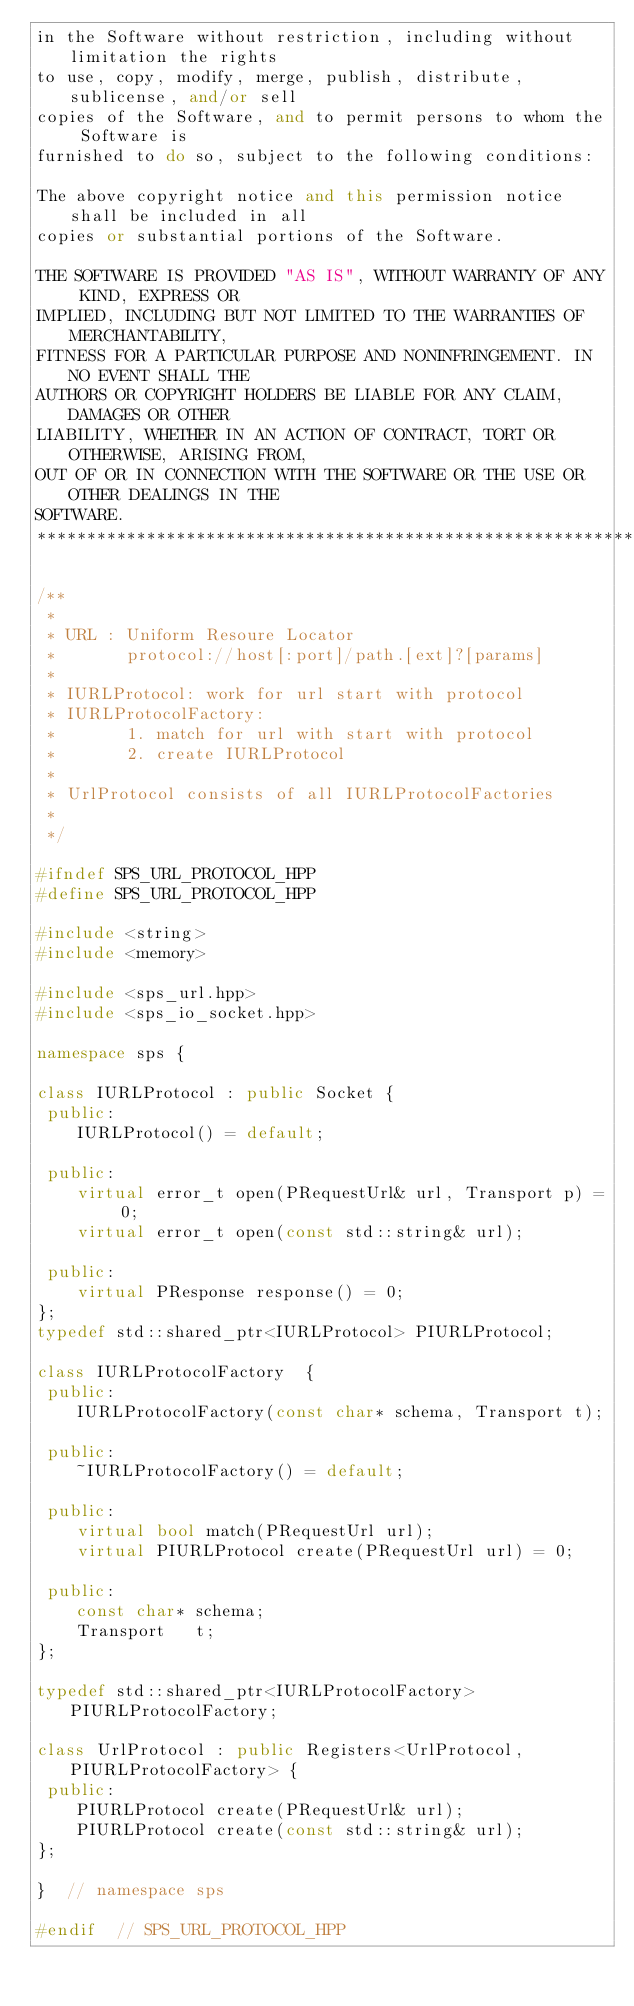Convert code to text. <code><loc_0><loc_0><loc_500><loc_500><_C++_>in the Software without restriction, including without limitation the rights
to use, copy, modify, merge, publish, distribute, sublicense, and/or sell
copies of the Software, and to permit persons to whom the Software is
furnished to do so, subject to the following conditions:

The above copyright notice and this permission notice shall be included in all
copies or substantial portions of the Software.

THE SOFTWARE IS PROVIDED "AS IS", WITHOUT WARRANTY OF ANY KIND, EXPRESS OR
IMPLIED, INCLUDING BUT NOT LIMITED TO THE WARRANTIES OF MERCHANTABILITY,
FITNESS FOR A PARTICULAR PURPOSE AND NONINFRINGEMENT. IN NO EVENT SHALL THE
AUTHORS OR COPYRIGHT HOLDERS BE LIABLE FOR ANY CLAIM, DAMAGES OR OTHER
LIABILITY, WHETHER IN AN ACTION OF CONTRACT, TORT OR OTHERWISE, ARISING FROM,
OUT OF OR IN CONNECTION WITH THE SOFTWARE OR THE USE OR OTHER DEALINGS IN THE
SOFTWARE.
*****************************************************************************/

/**
 *
 * URL : Uniform Resoure Locator
 *       protocol://host[:port]/path.[ext]?[params]
 *
 * IURLProtocol: work for url start with protocol
 * IURLProtocolFactory:
 *       1. match for url with start with protocol
 *       2. create IURLProtocol
 *
 * UrlProtocol consists of all IURLProtocolFactories
 *
 */

#ifndef SPS_URL_PROTOCOL_HPP
#define SPS_URL_PROTOCOL_HPP

#include <string>
#include <memory>

#include <sps_url.hpp>
#include <sps_io_socket.hpp>

namespace sps {

class IURLProtocol : public Socket {
 public:
    IURLProtocol() = default;

 public:
    virtual error_t open(PRequestUrl& url, Transport p) = 0;
    virtual error_t open(const std::string& url);

 public:
    virtual PResponse response() = 0;
};
typedef std::shared_ptr<IURLProtocol> PIURLProtocol;

class IURLProtocolFactory  {
 public:
    IURLProtocolFactory(const char* schema, Transport t);

 public:
    ~IURLProtocolFactory() = default;

 public:
    virtual bool match(PRequestUrl url);
    virtual PIURLProtocol create(PRequestUrl url) = 0;

 public:
    const char* schema;
    Transport   t;
};

typedef std::shared_ptr<IURLProtocolFactory> PIURLProtocolFactory;

class UrlProtocol : public Registers<UrlProtocol, PIURLProtocolFactory> {
 public:
    PIURLProtocol create(PRequestUrl& url);
    PIURLProtocol create(const std::string& url);
};

}  // namespace sps

#endif  // SPS_URL_PROTOCOL_HPP
</code> 